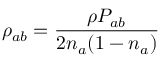Convert formula to latex. <formula><loc_0><loc_0><loc_500><loc_500>\rho _ { a b } = \frac { \rho P _ { a b } } { 2 n _ { a } ( 1 - n _ { a } ) }</formula> 